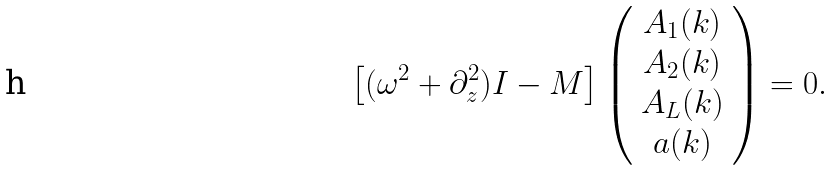<formula> <loc_0><loc_0><loc_500><loc_500>\left [ ( \omega ^ { 2 } + \partial _ { z } ^ { 2 } ) { I } - M \right ] \left ( \begin{array} { c } A _ { 1 } ( k ) \\ A _ { 2 } ( k ) \\ A _ { L } ( k ) \\ a ( k ) \\ \end{array} \right ) = 0 .</formula> 